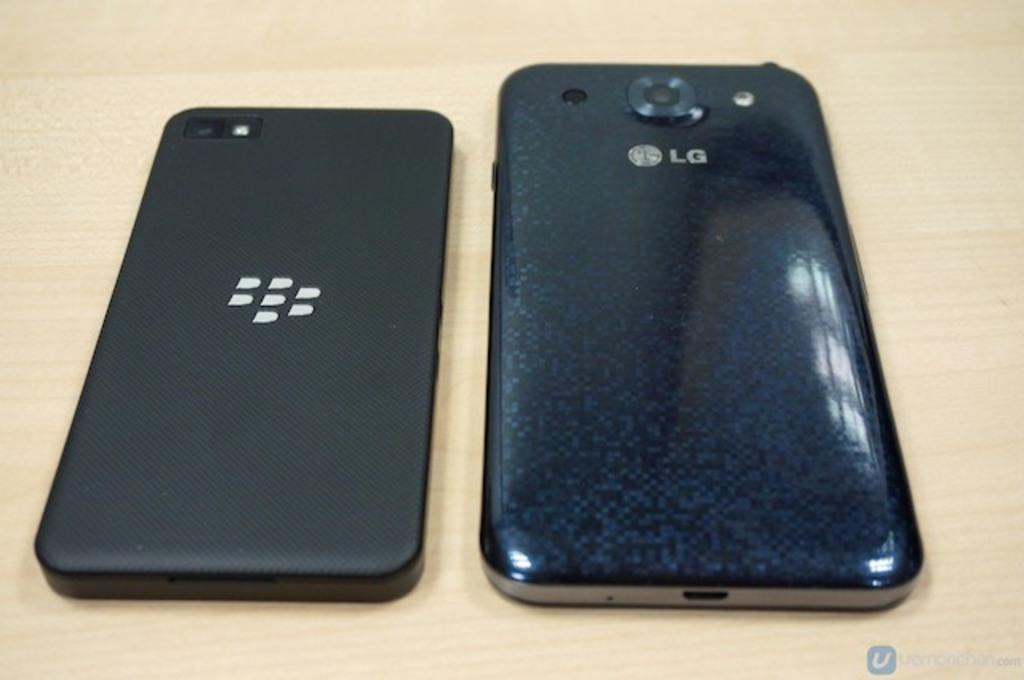<image>
Give a short and clear explanation of the subsequent image. two black cell phones including one from LG on a wood table 